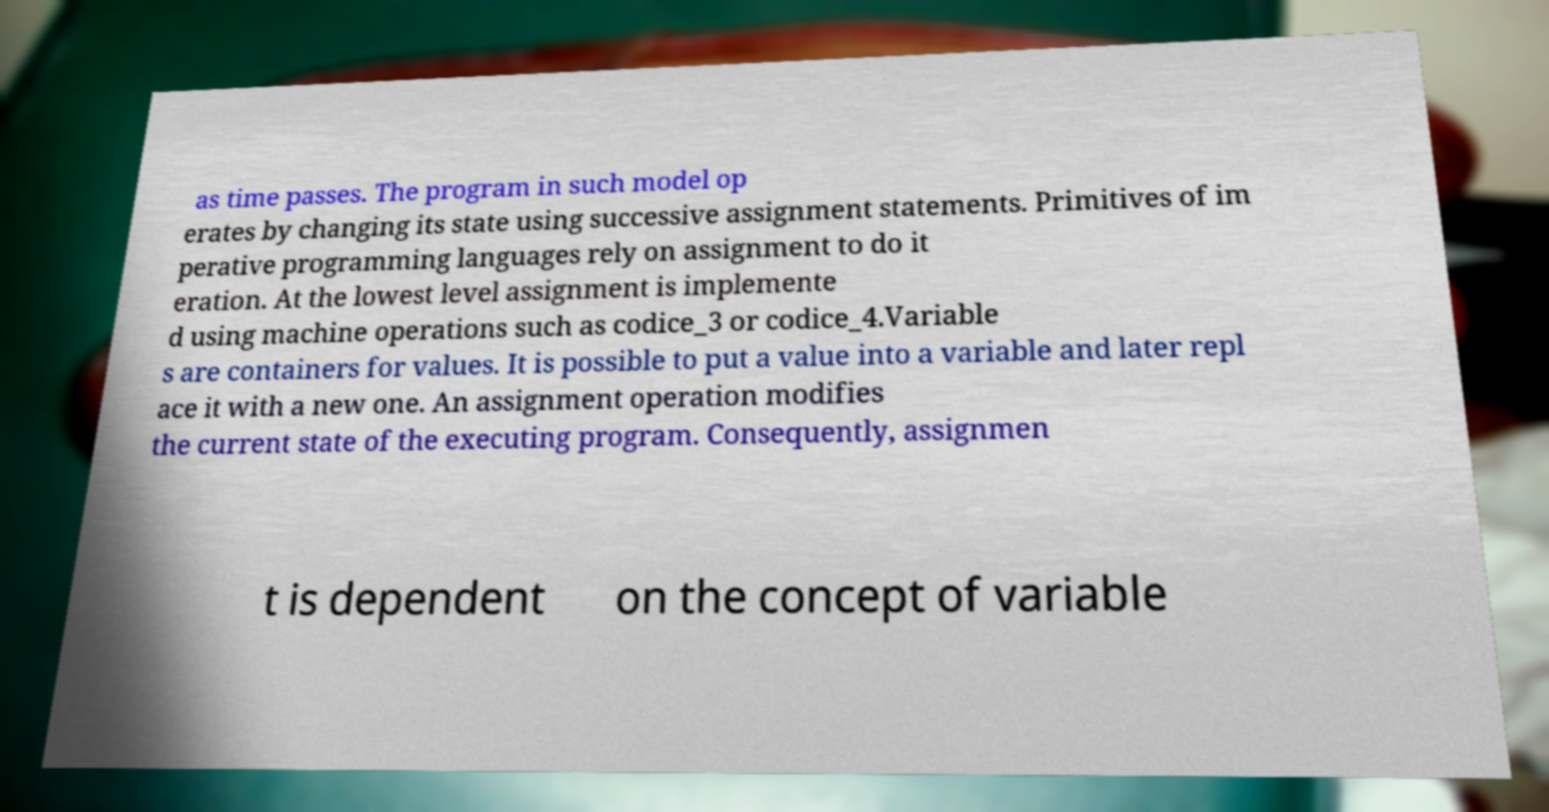Please identify and transcribe the text found in this image. as time passes. The program in such model op erates by changing its state using successive assignment statements. Primitives of im perative programming languages rely on assignment to do it eration. At the lowest level assignment is implemente d using machine operations such as codice_3 or codice_4.Variable s are containers for values. It is possible to put a value into a variable and later repl ace it with a new one. An assignment operation modifies the current state of the executing program. Consequently, assignmen t is dependent on the concept of variable 